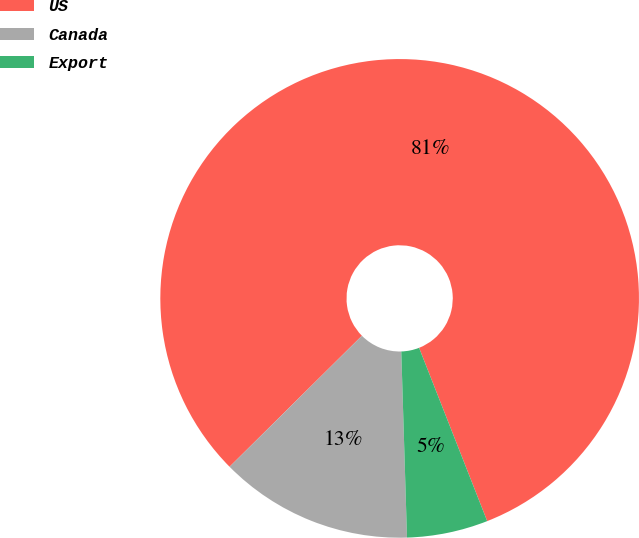Convert chart. <chart><loc_0><loc_0><loc_500><loc_500><pie_chart><fcel>US<fcel>Canada<fcel>Export<nl><fcel>81.46%<fcel>13.07%<fcel>5.47%<nl></chart> 